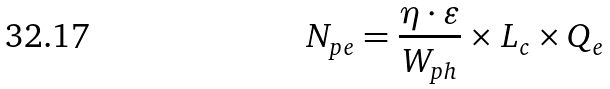<formula> <loc_0><loc_0><loc_500><loc_500>N _ { p e } = \frac { \eta \cdot \varepsilon } { W _ { p h } } \times L _ { c } \times Q _ { e }</formula> 